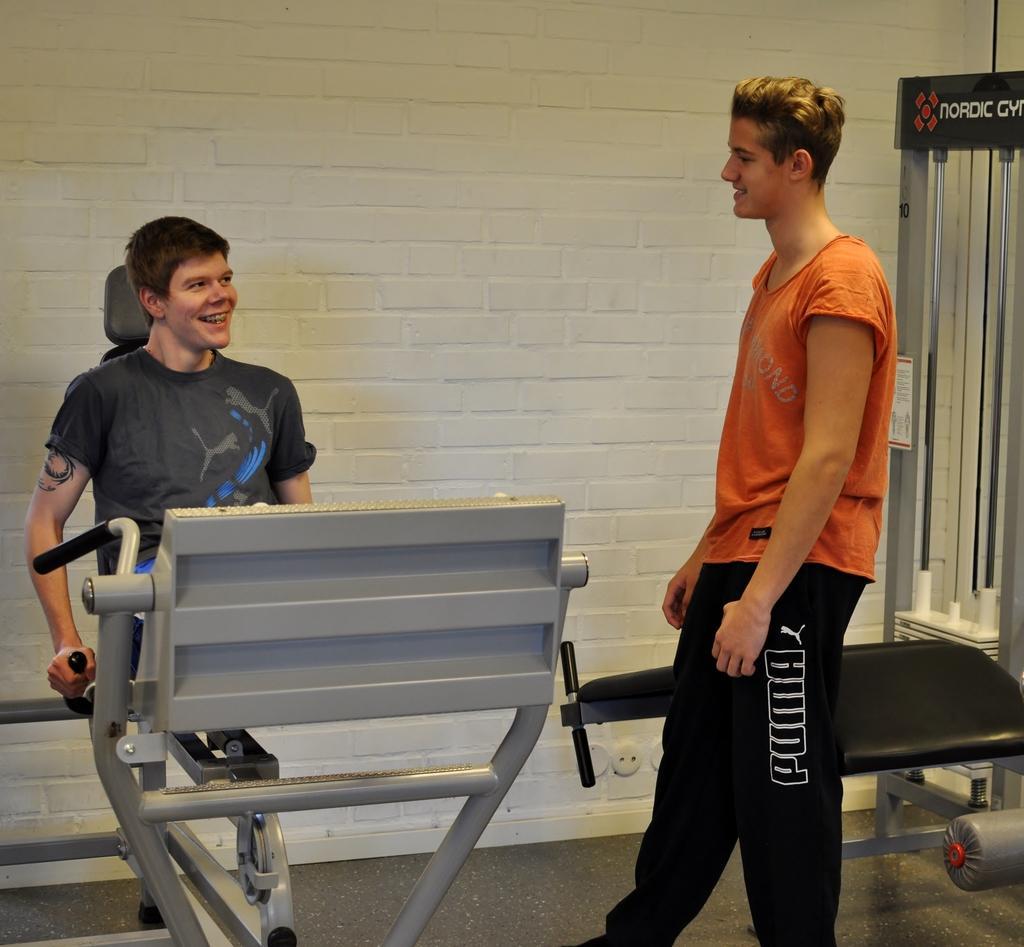Can you describe this image briefly? In this image there is a man standing on a floor and a man sitting on a workout machine, in the background there is a wall. 